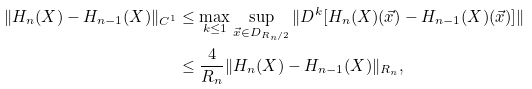Convert formula to latex. <formula><loc_0><loc_0><loc_500><loc_500>\| H _ { n } ( X ) - H _ { n - 1 } ( X ) \| _ { C ^ { 1 } } & \leq \max _ { k \leq 1 } \sup _ { \vec { x } \in D _ { R _ { n } / 2 } } \| D ^ { k } [ H _ { n } ( X ) ( \vec { x } ) - H _ { n - 1 } ( X ) ( \vec { x } ) ] \| \\ & \leq \frac { 4 } { R _ { n } } \| H _ { n } ( X ) - H _ { n - 1 } ( X ) \| _ { R _ { n } } ,</formula> 